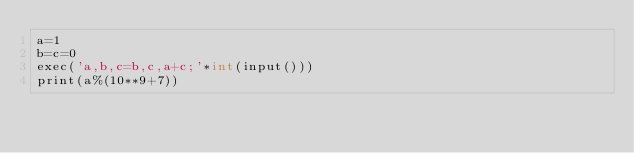Convert code to text. <code><loc_0><loc_0><loc_500><loc_500><_Cython_>a=1
b=c=0
exec('a,b,c=b,c,a+c;'*int(input()))
print(a%(10**9+7))</code> 